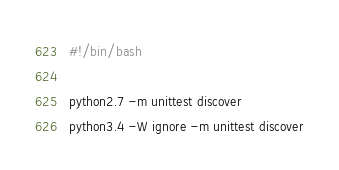Convert code to text. <code><loc_0><loc_0><loc_500><loc_500><_Bash_>#!/bin/bash

python2.7 -m unittest discover
python3.4 -W ignore -m unittest discover</code> 